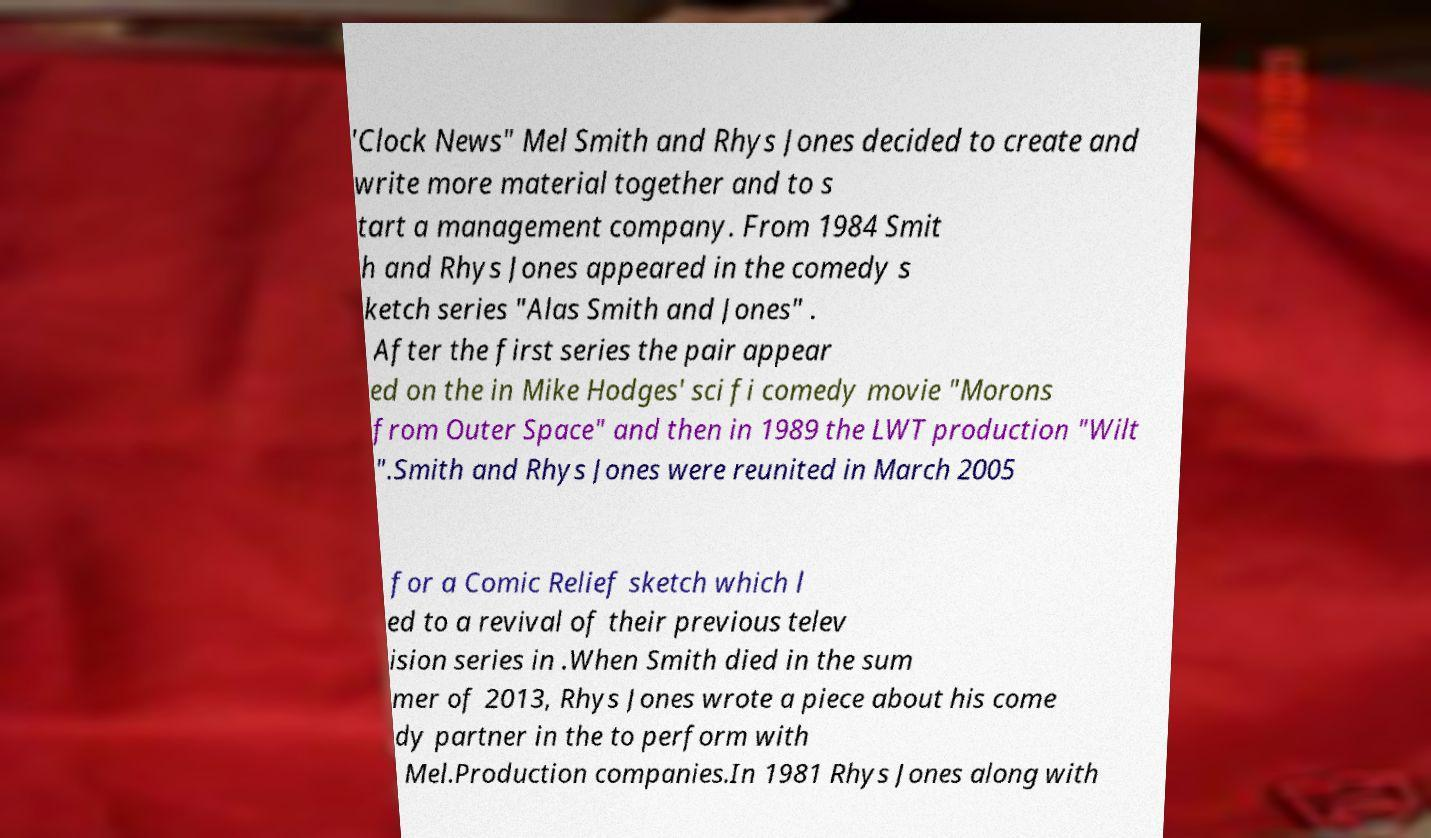There's text embedded in this image that I need extracted. Can you transcribe it verbatim? 'Clock News" Mel Smith and Rhys Jones decided to create and write more material together and to s tart a management company. From 1984 Smit h and Rhys Jones appeared in the comedy s ketch series "Alas Smith and Jones" . After the first series the pair appear ed on the in Mike Hodges' sci fi comedy movie "Morons from Outer Space" and then in 1989 the LWT production "Wilt ".Smith and Rhys Jones were reunited in March 2005 for a Comic Relief sketch which l ed to a revival of their previous telev ision series in .When Smith died in the sum mer of 2013, Rhys Jones wrote a piece about his come dy partner in the to perform with Mel.Production companies.In 1981 Rhys Jones along with 